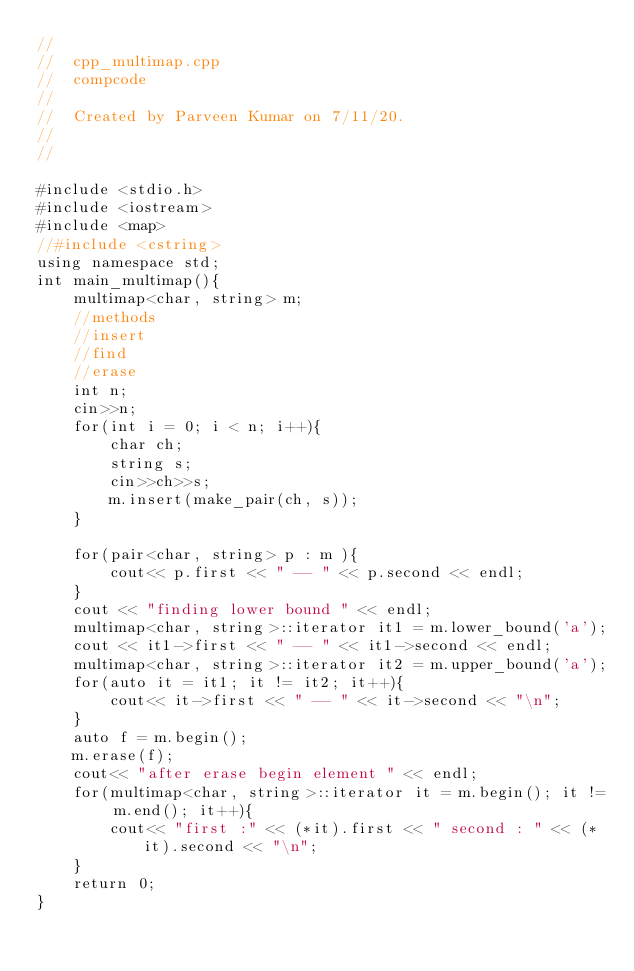Convert code to text. <code><loc_0><loc_0><loc_500><loc_500><_C++_>//
//  cpp_multimap.cpp
//  compcode
//
//  Created by Parveen Kumar on 7/11/20.
//
//

#include <stdio.h>
#include <iostream>
#include <map>
//#include <cstring>
using namespace std;
int main_multimap(){
    multimap<char, string> m;
    //methods
    //insert
    //find
    //erase
    int n;
    cin>>n;
    for(int i = 0; i < n; i++){
        char ch;
        string s;
        cin>>ch>>s;
        m.insert(make_pair(ch, s));
    }
    
    for(pair<char, string> p : m ){
        cout<< p.first << " -- " << p.second << endl;
    }
    cout << "finding lower bound " << endl;
    multimap<char, string>::iterator it1 = m.lower_bound('a');
    cout << it1->first << " -- " << it1->second << endl;
    multimap<char, string>::iterator it2 = m.upper_bound('a');
    for(auto it = it1; it != it2; it++){
        cout<< it->first << " -- " << it->second << "\n";
    }
    auto f = m.begin();
    m.erase(f);
    cout<< "after erase begin element " << endl;
    for(multimap<char, string>::iterator it = m.begin(); it != m.end(); it++){
        cout<< "first :" << (*it).first << " second : " << (*it).second << "\n";
    }
    return 0;
}
</code> 